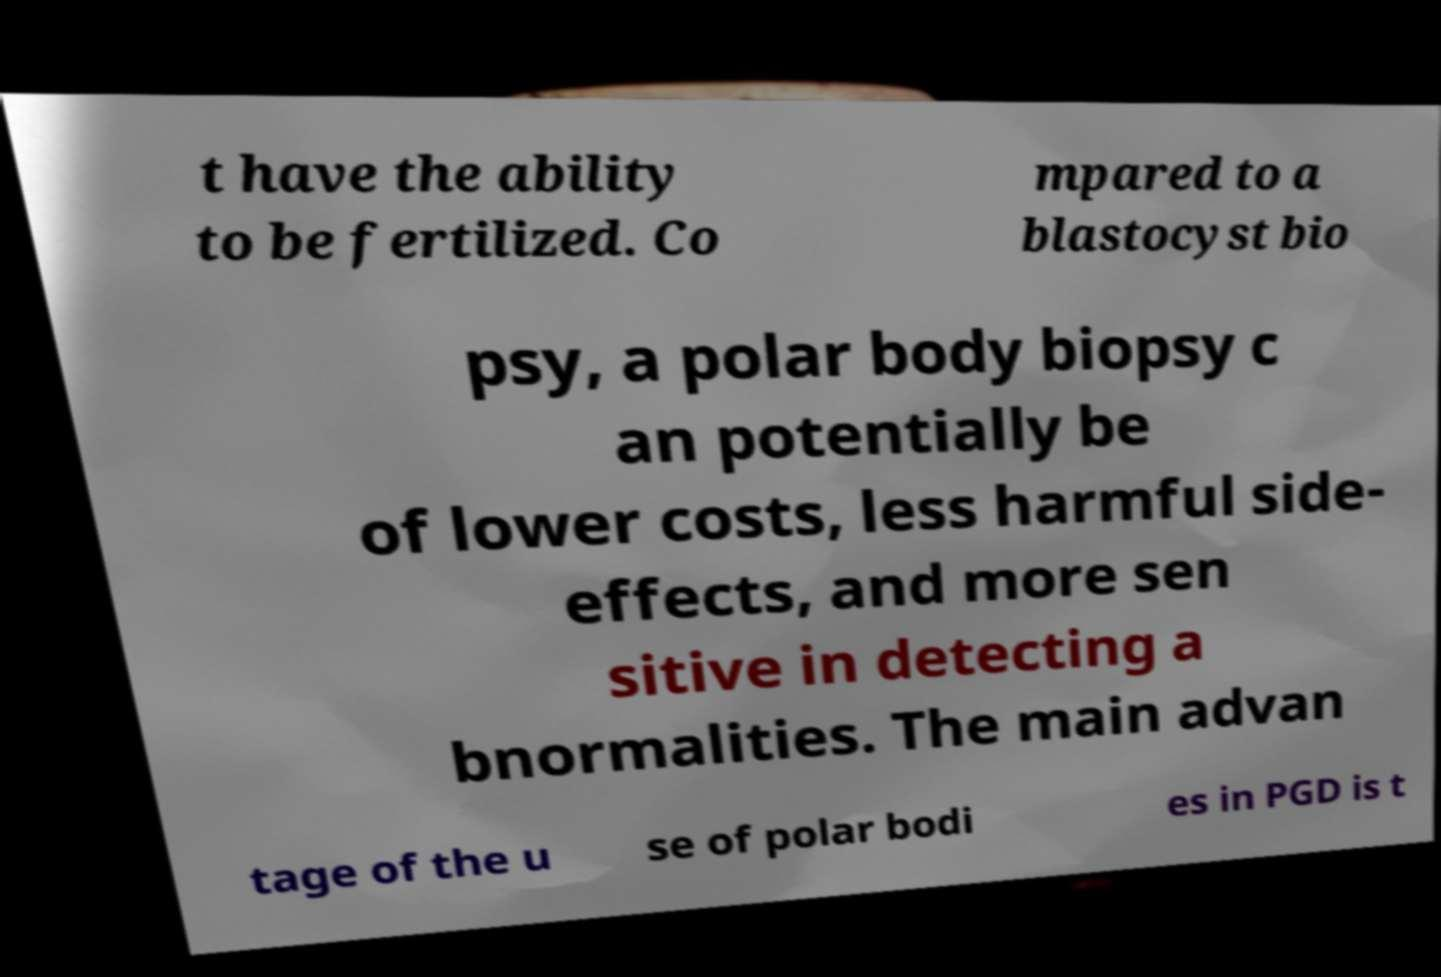Could you assist in decoding the text presented in this image and type it out clearly? t have the ability to be fertilized. Co mpared to a blastocyst bio psy, a polar body biopsy c an potentially be of lower costs, less harmful side- effects, and more sen sitive in detecting a bnormalities. The main advan tage of the u se of polar bodi es in PGD is t 